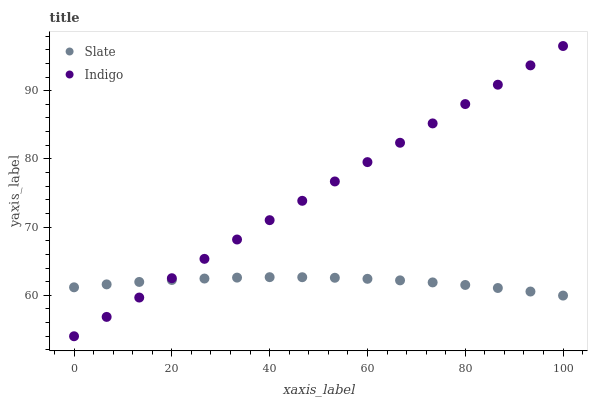Does Slate have the minimum area under the curve?
Answer yes or no. Yes. Does Indigo have the maximum area under the curve?
Answer yes or no. Yes. Does Indigo have the minimum area under the curve?
Answer yes or no. No. Is Indigo the smoothest?
Answer yes or no. Yes. Is Slate the roughest?
Answer yes or no. Yes. Is Indigo the roughest?
Answer yes or no. No. Does Indigo have the lowest value?
Answer yes or no. Yes. Does Indigo have the highest value?
Answer yes or no. Yes. Does Indigo intersect Slate?
Answer yes or no. Yes. Is Indigo less than Slate?
Answer yes or no. No. Is Indigo greater than Slate?
Answer yes or no. No. 